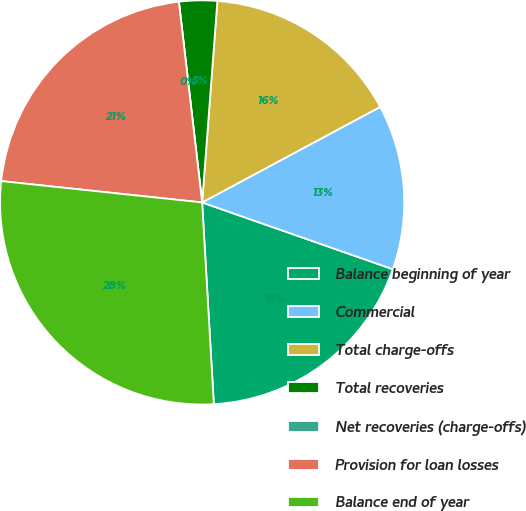Convert chart to OTSL. <chart><loc_0><loc_0><loc_500><loc_500><pie_chart><fcel>Balance beginning of year<fcel>Commercial<fcel>Total charge-offs<fcel>Total recoveries<fcel>Net recoveries (charge-offs)<fcel>Provision for loan losses<fcel>Balance end of year<nl><fcel>18.72%<fcel>13.2%<fcel>15.96%<fcel>3.04%<fcel>0.0%<fcel>21.48%<fcel>27.61%<nl></chart> 